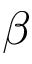<formula> <loc_0><loc_0><loc_500><loc_500>\beta</formula> 